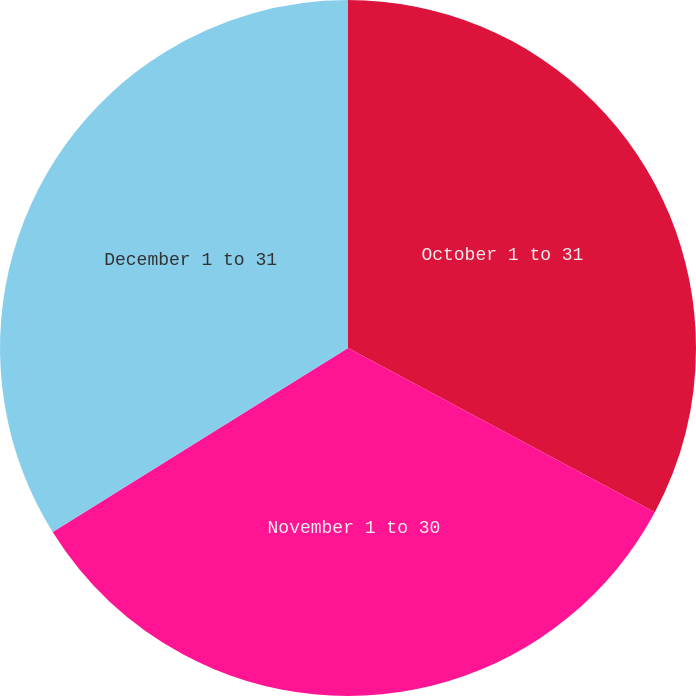Convert chart. <chart><loc_0><loc_0><loc_500><loc_500><pie_chart><fcel>October 1 to 31<fcel>November 1 to 30<fcel>December 1 to 31<nl><fcel>32.82%<fcel>33.31%<fcel>33.87%<nl></chart> 